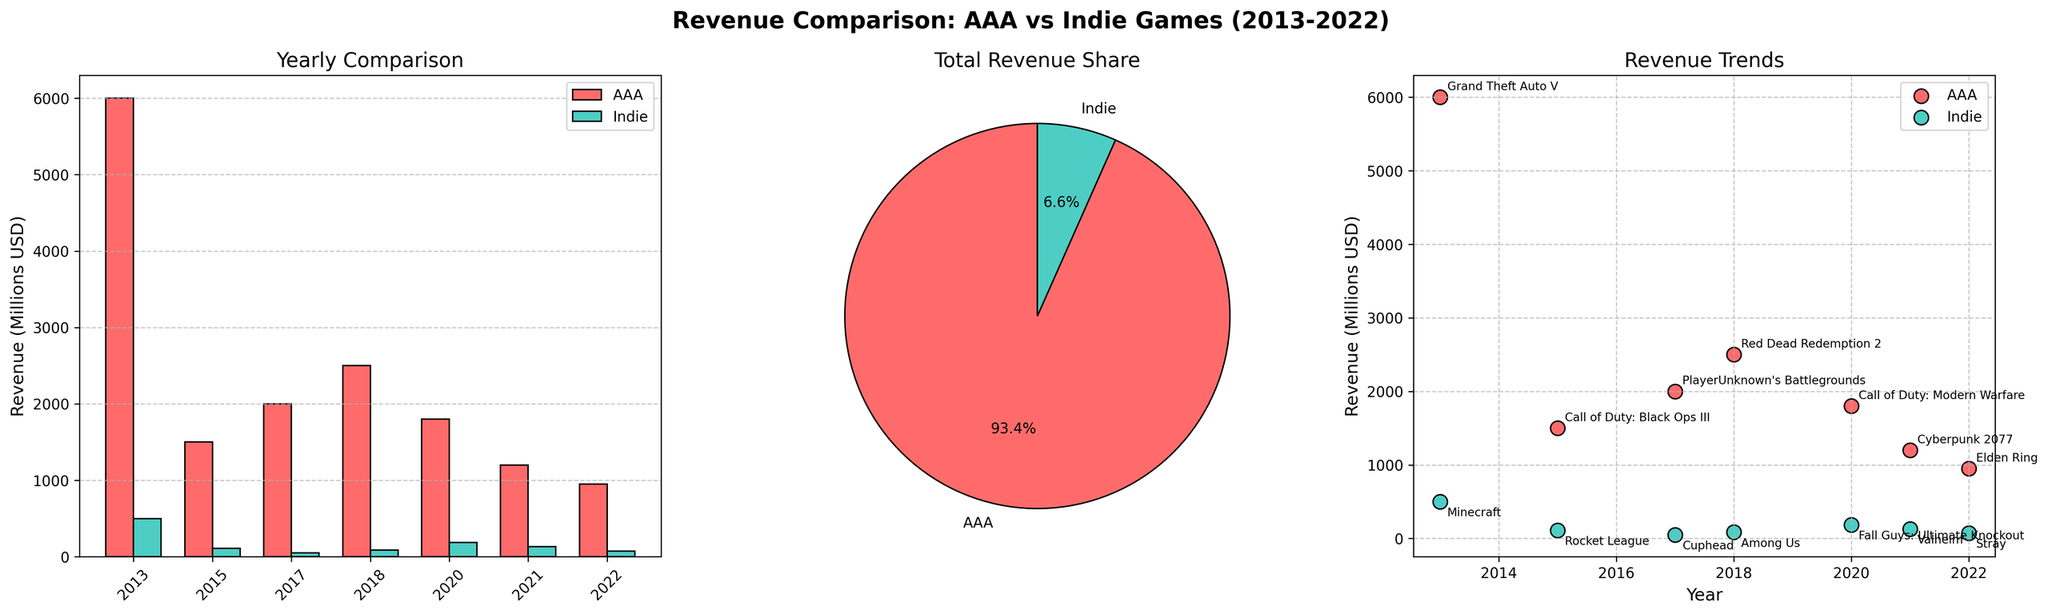what is the title of the figure? The title of the figure is generally found at the top center of the plots and is usually larger in font compared to other text in the figure. The title in this instance is located at the very top in bold text.
Answer: Revenue Comparison: AAA vs Indie Games (2013-2022) Which game title had the highest revenue among Indie games? To find the game title with the highest revenue among Indie games, look at the bar representing Indie games with the highest height in the bar plot or the highest point in the scatter plot within the respective color (aqua). The figure indicates the highest revenue in the scatter plot for Indie games.
Answer: Minecraft What was the total revenue share of AAA games versus Indie games? By examining the pie chart, which shows the total revenue share between AAA and Indie games, identify the larger slice which represents AAA. Each slice has a percentage label. The AAA slice covers a larger portion than the Indie slice.
Answer: 86.0% for AAA and 14.0% for Indie What year did Indie games reach their highest revenue, and what game achieved it? The scatter plot provides information where each point represents a game. Look for the highest point in the Indie color (aqua) and check the associated year and title label next to that point. The highest Indie revenue point occurs in 2013.
Answer: 2013, Minecraft How do the yearly revenue trends of AAA versus Indie games differ? To understand the trends, compare the scatter points of AAA games (red) and Indie games (aqua) over the years. AAA points appear consistently higher compared to Indie points, and specific high revenue, such as in 2013 and 2018 for AAA, are significantly more. Indie games show increasing but far lower revenue over the years.
Answer: AAA games show much higher and more consistent revenue growth compared to Indie games, which have a more modest and less consistent increase What is the average annual revenue for AAA games from 2013 to 2022? To find the average revenue, sum the revenues of all AAA games from the years 2013 to 2022, then divide by the number of data points (years with AAA games). The revenues sum up to 18,950 million USD, and there are 7 data points. Calculate 18,950 divided by 7.
Answer: 2,707 million USD Which had the least revenue among AAA games, and how much was it? The lowest bar in the bar chart for AAA games or the lowest point in the scatter plot for AAA revenues indicates the lowest revenue value. Label the respective year and title from that point. The year and title, as represented in the bar plot and scatter plot, gives the answer.
Answer: Elden Ring, 950 million USD What is the revenue difference between Minecraft and Cuphead? Find the revenue of Minecraft and Cuphead from either the bar plot or the scatter plot, then subtract the revenue of Cuphead from that of Minecraft. Minecraft has 500 million USD, and Cuphead has 50 million USD. Calculate 500 minus 50.
Answer: 450 million USD Which indie game had the highest revenue in 2020? Check the scatter plot for the year 2020 and find the Indie game data point labeled with the game title and its revenue. The point with a higher value for Indie games shows the title in 2020.
Answer: Fall Guys: Ultimate Knockout 